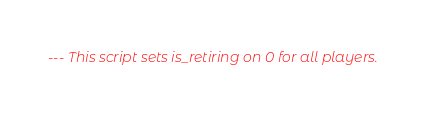<code> <loc_0><loc_0><loc_500><loc_500><_Lua_>--- This script sets is_retiring on 0 for all players.</code> 